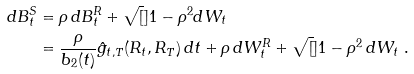<formula> <loc_0><loc_0><loc_500><loc_500>d B _ { t } ^ { S } & = \rho \, d B _ { t } ^ { R } + \sqrt { [ } ] { 1 - \rho ^ { 2 } } d W _ { t } \\ & = \frac { \rho } { b _ { 2 } ( t ) } \hat { g } _ { t , T } ( R _ { t } , R _ { T } ) \, d t + \rho \, d W _ { t } ^ { R } + \sqrt { [ } ] { 1 - \rho ^ { 2 } } \, d W _ { t } \ .</formula> 